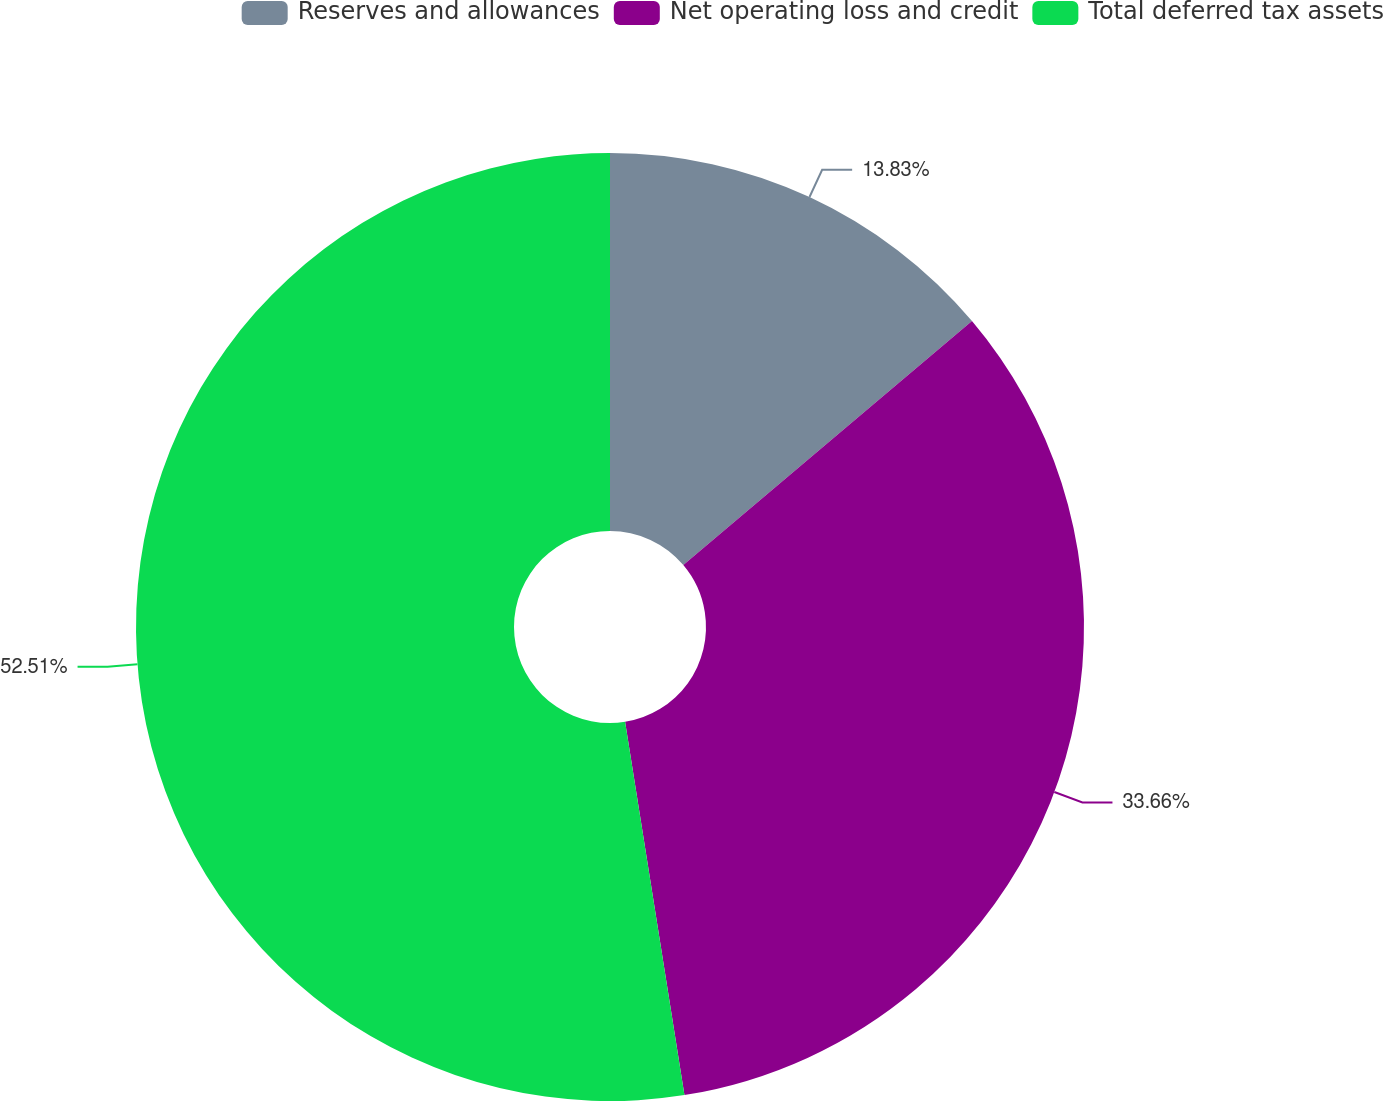Convert chart to OTSL. <chart><loc_0><loc_0><loc_500><loc_500><pie_chart><fcel>Reserves and allowances<fcel>Net operating loss and credit<fcel>Total deferred tax assets<nl><fcel>13.83%<fcel>33.66%<fcel>52.51%<nl></chart> 